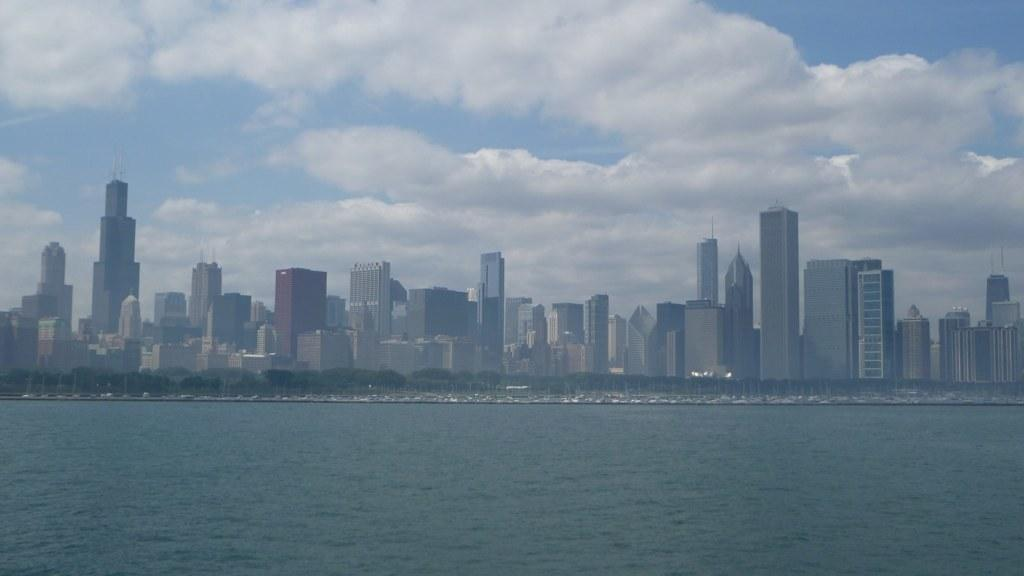What can be seen in the middle of the image? There are buildings and trees in the middle of the image. What is visible at the bottom of the image? There are waves and water visible at the bottom of the image. What is visible at the top of the image? There is sky visible at the top of the image, and there are clouds visible in the sky. What type of honey is being used to write letters on the trees in the image? There is no honey or letters present in the image; it features buildings, trees, waves, water, sky, and clouds. Can you see a pencil being used to draw on the buildings in the image? There is no pencil or drawing activity present in the image; it only shows buildings, trees, waves, water, sky, and clouds. 